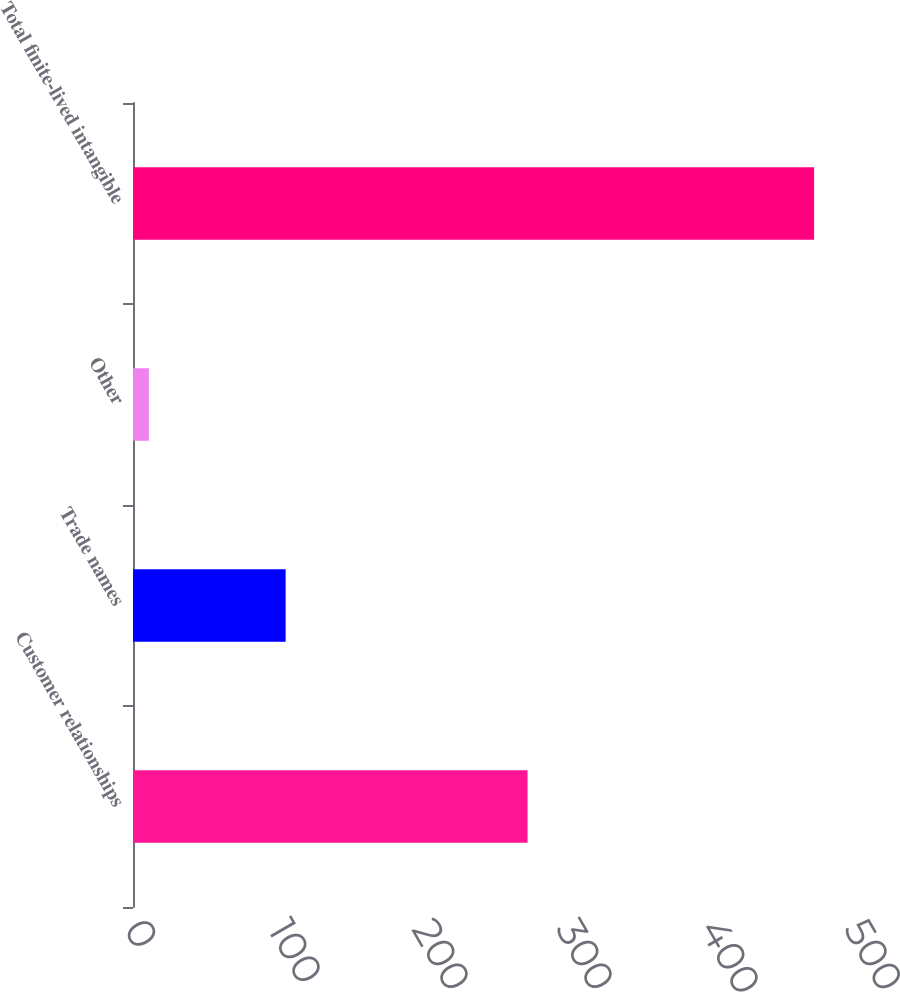Convert chart to OTSL. <chart><loc_0><loc_0><loc_500><loc_500><bar_chart><fcel>Customer relationships<fcel>Trade names<fcel>Other<fcel>Total finite-lived intangible<nl><fcel>274<fcel>106<fcel>11<fcel>473<nl></chart> 